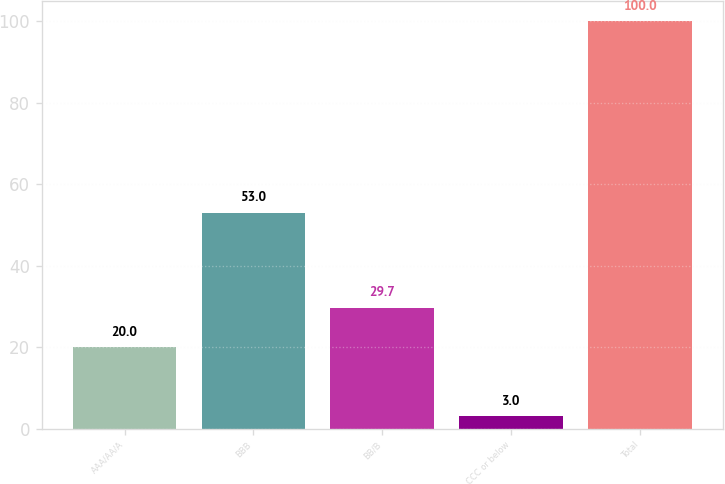Convert chart. <chart><loc_0><loc_0><loc_500><loc_500><bar_chart><fcel>AAA/AA/A<fcel>BBB<fcel>BB/B<fcel>CCC or below<fcel>Total<nl><fcel>20<fcel>53<fcel>29.7<fcel>3<fcel>100<nl></chart> 